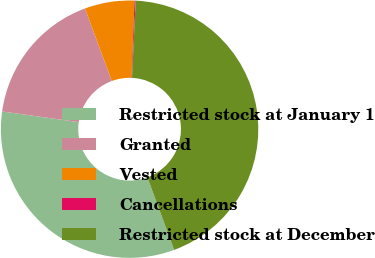<chart> <loc_0><loc_0><loc_500><loc_500><pie_chart><fcel>Restricted stock at January 1<fcel>Granted<fcel>Vested<fcel>Cancellations<fcel>Restricted stock at December<nl><fcel>32.83%<fcel>17.17%<fcel>6.24%<fcel>0.14%<fcel>43.62%<nl></chart> 